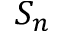Convert formula to latex. <formula><loc_0><loc_0><loc_500><loc_500>S _ { n }</formula> 